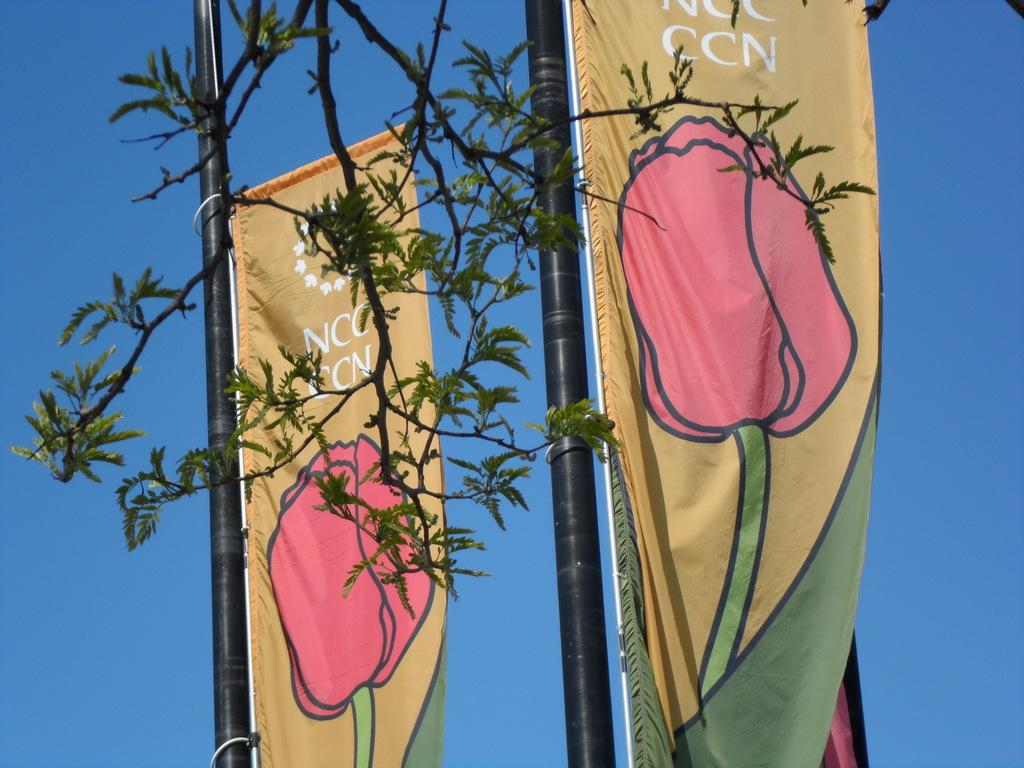What objects are on black poles in the image? There are flags on black poles in the image. What design can be seen on the flags? The flags have a design of a flower. What natural element is visible at the top of the image? There is a tree branch visible at the top of the image. What can be seen in the background of the image? The sky is visible in the background of the image. What type of wool is being spun on the ground in the image? There is no wool or spinning activity present in the image; it features flags on black poles with a flower design. 